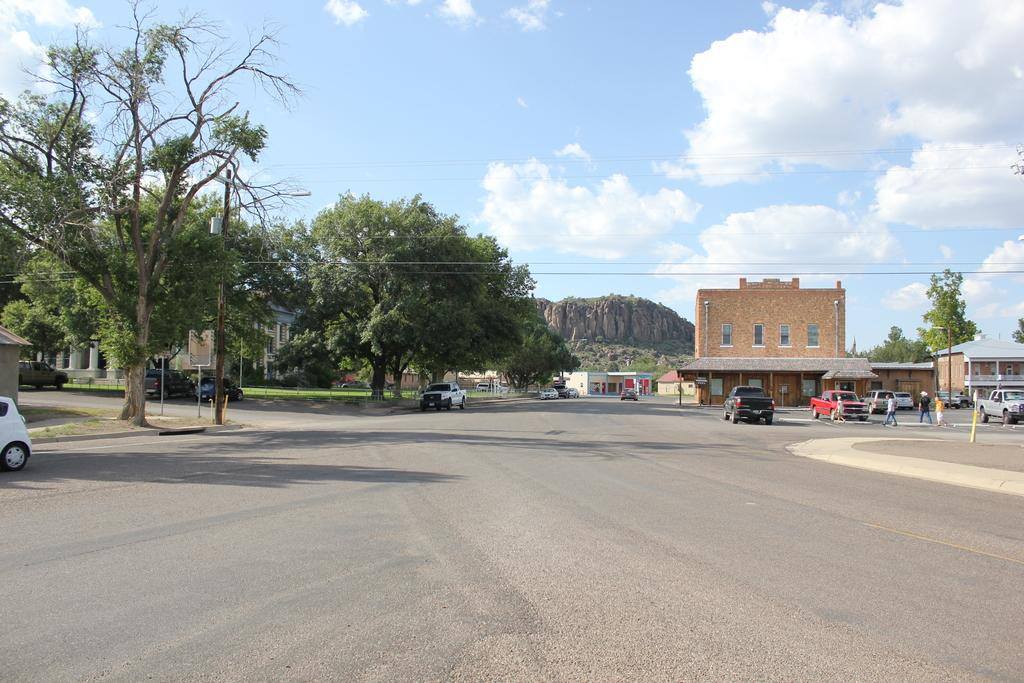What type of natural elements can be seen in the image? There are trees in the image. What type of man-made structures can be seen in the image? There are buildings and fencing in the image. What part of the natural environment is visible in the image? The sky is visible in the image. What type of infrastructure can be seen in the image? There are poles and wires in the image. What architectural features can be seen in the buildings? There are windows in the buildings. What type of geological feature can be seen in the image? There is a rock in the image. What type of living organisms can be seen in the image? There are people in the image. What type of transportation can be seen in the image? There are vehicles on the road in the image. What type of bait is being used to catch fish in the image? There is no fishing or bait present in the image. What type of comfort can be seen in the image? The image does not depict any specific comfort or relaxation. 